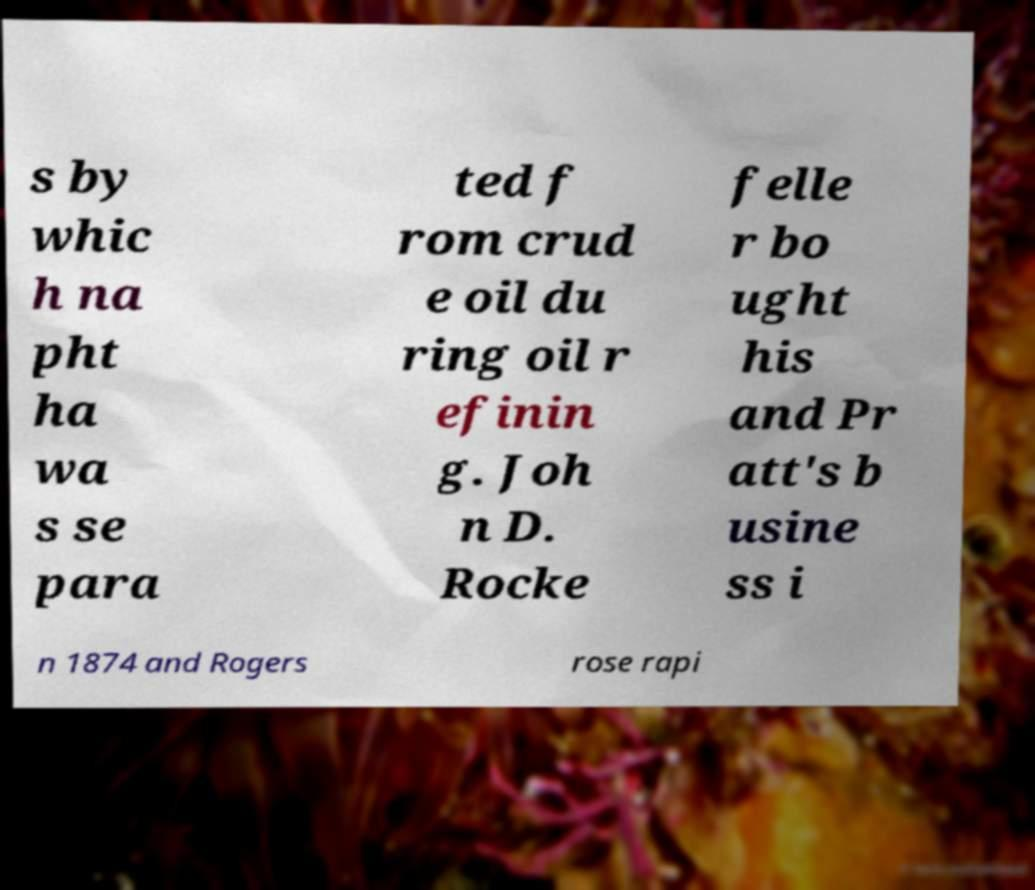There's text embedded in this image that I need extracted. Can you transcribe it verbatim? s by whic h na pht ha wa s se para ted f rom crud e oil du ring oil r efinin g. Joh n D. Rocke felle r bo ught his and Pr att's b usine ss i n 1874 and Rogers rose rapi 